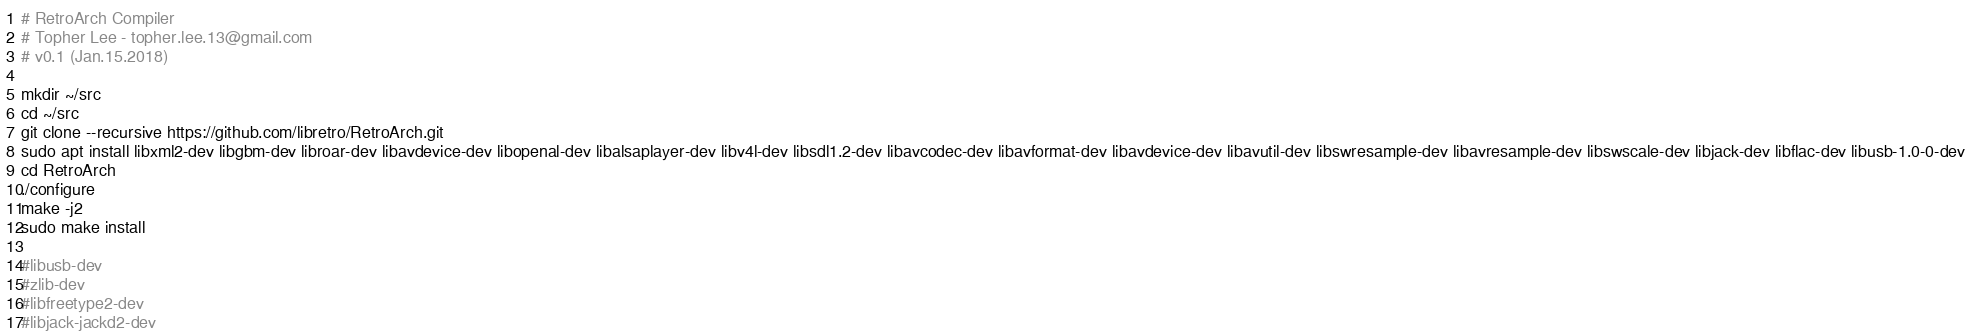<code> <loc_0><loc_0><loc_500><loc_500><_Bash_># RetroArch Compiler
# Topher Lee - topher.lee.13@gmail.com
# v0.1 (Jan.15.2018)

mkdir ~/src
cd ~/src
git clone --recursive https://github.com/libretro/RetroArch.git
sudo apt install libxml2-dev libgbm-dev libroar-dev libavdevice-dev libopenal-dev libalsaplayer-dev libv4l-dev libsdl1.2-dev libavcodec-dev libavformat-dev libavdevice-dev libavutil-dev libswresample-dev libavresample-dev libswscale-dev libjack-dev libflac-dev libusb-1.0-0-dev
cd RetroArch
./configure
make -j2
sudo make install

#libusb-dev
#zlib-dev
#libfreetype2-dev
#libjack-jackd2-dev

</code> 